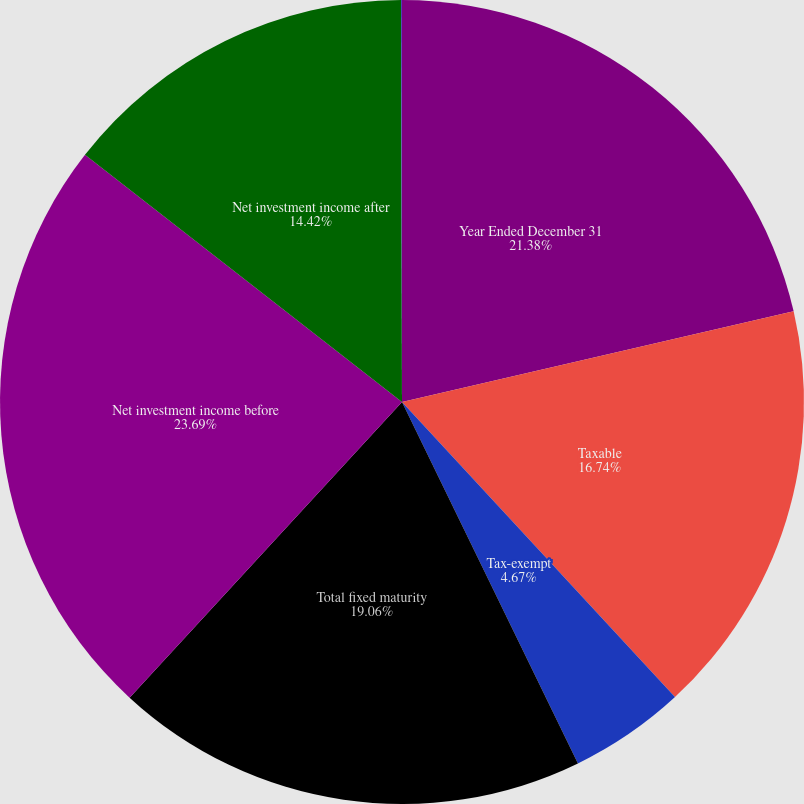Convert chart. <chart><loc_0><loc_0><loc_500><loc_500><pie_chart><fcel>Year Ended December 31<fcel>Taxable<fcel>Tax-exempt<fcel>Total fixed maturity<fcel>Net investment income before<fcel>Net investment income after<fcel>Effective income yield for the<nl><fcel>21.38%<fcel>16.74%<fcel>4.67%<fcel>19.06%<fcel>23.69%<fcel>14.42%<fcel>0.04%<nl></chart> 